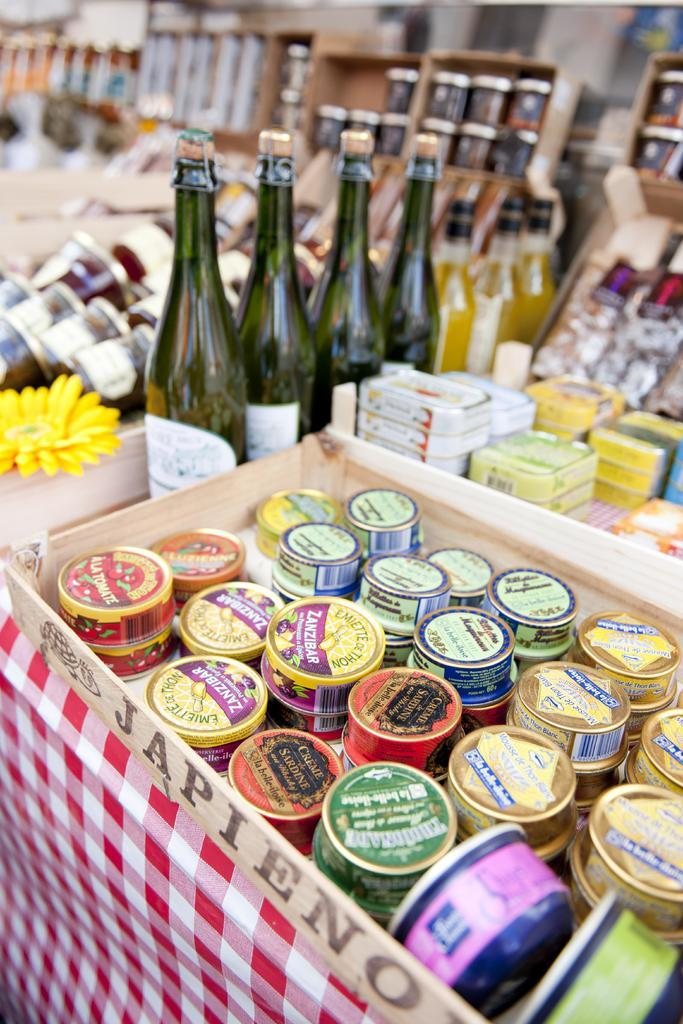Provide a one-sentence caption for the provided image. Bottles next to tiny containers which say "CREME" on it. 